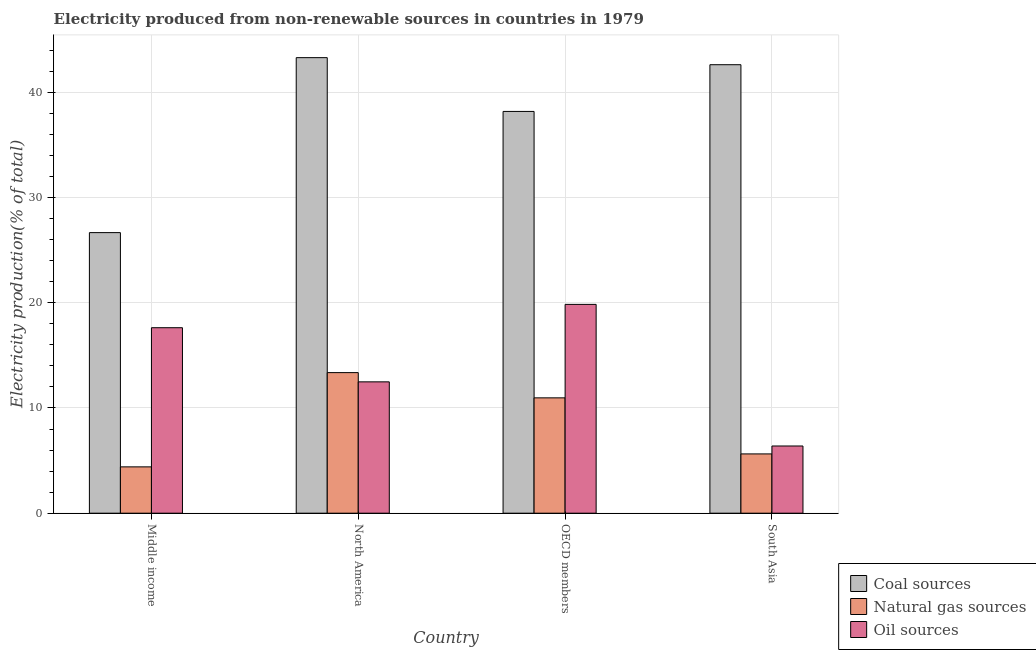How many different coloured bars are there?
Your answer should be compact. 3. How many groups of bars are there?
Your response must be concise. 4. How many bars are there on the 1st tick from the left?
Your response must be concise. 3. How many bars are there on the 3rd tick from the right?
Offer a very short reply. 3. What is the percentage of electricity produced by oil sources in Middle income?
Offer a very short reply. 17.63. Across all countries, what is the maximum percentage of electricity produced by oil sources?
Give a very brief answer. 19.85. Across all countries, what is the minimum percentage of electricity produced by natural gas?
Your response must be concise. 4.4. In which country was the percentage of electricity produced by oil sources minimum?
Offer a terse response. South Asia. What is the total percentage of electricity produced by natural gas in the graph?
Your answer should be compact. 34.36. What is the difference between the percentage of electricity produced by coal in Middle income and that in OECD members?
Provide a short and direct response. -11.52. What is the difference between the percentage of electricity produced by natural gas in Middle income and the percentage of electricity produced by oil sources in South Asia?
Offer a terse response. -1.98. What is the average percentage of electricity produced by coal per country?
Provide a succinct answer. 37.69. What is the difference between the percentage of electricity produced by natural gas and percentage of electricity produced by oil sources in South Asia?
Give a very brief answer. -0.75. What is the ratio of the percentage of electricity produced by coal in North America to that in OECD members?
Give a very brief answer. 1.13. What is the difference between the highest and the second highest percentage of electricity produced by coal?
Give a very brief answer. 0.67. What is the difference between the highest and the lowest percentage of electricity produced by coal?
Ensure brevity in your answer.  16.63. Is the sum of the percentage of electricity produced by natural gas in North America and South Asia greater than the maximum percentage of electricity produced by oil sources across all countries?
Offer a very short reply. No. What does the 3rd bar from the left in Middle income represents?
Provide a short and direct response. Oil sources. What does the 2nd bar from the right in North America represents?
Provide a short and direct response. Natural gas sources. Are all the bars in the graph horizontal?
Provide a short and direct response. No. Are the values on the major ticks of Y-axis written in scientific E-notation?
Offer a terse response. No. Does the graph contain any zero values?
Give a very brief answer. No. Does the graph contain grids?
Your answer should be compact. Yes. Where does the legend appear in the graph?
Provide a short and direct response. Bottom right. How many legend labels are there?
Offer a very short reply. 3. How are the legend labels stacked?
Your response must be concise. Vertical. What is the title of the graph?
Make the answer very short. Electricity produced from non-renewable sources in countries in 1979. What is the label or title of the X-axis?
Your answer should be very brief. Country. What is the label or title of the Y-axis?
Offer a very short reply. Electricity production(% of total). What is the Electricity production(% of total) of Coal sources in Middle income?
Your response must be concise. 26.66. What is the Electricity production(% of total) in Natural gas sources in Middle income?
Make the answer very short. 4.4. What is the Electricity production(% of total) in Oil sources in Middle income?
Offer a very short reply. 17.63. What is the Electricity production(% of total) of Coal sources in North America?
Provide a succinct answer. 43.29. What is the Electricity production(% of total) in Natural gas sources in North America?
Provide a succinct answer. 13.36. What is the Electricity production(% of total) of Oil sources in North America?
Offer a very short reply. 12.48. What is the Electricity production(% of total) in Coal sources in OECD members?
Your answer should be very brief. 38.18. What is the Electricity production(% of total) of Natural gas sources in OECD members?
Ensure brevity in your answer.  10.96. What is the Electricity production(% of total) of Oil sources in OECD members?
Your answer should be compact. 19.85. What is the Electricity production(% of total) in Coal sources in South Asia?
Make the answer very short. 42.62. What is the Electricity production(% of total) of Natural gas sources in South Asia?
Offer a very short reply. 5.63. What is the Electricity production(% of total) of Oil sources in South Asia?
Offer a terse response. 6.39. Across all countries, what is the maximum Electricity production(% of total) in Coal sources?
Offer a very short reply. 43.29. Across all countries, what is the maximum Electricity production(% of total) in Natural gas sources?
Ensure brevity in your answer.  13.36. Across all countries, what is the maximum Electricity production(% of total) of Oil sources?
Offer a very short reply. 19.85. Across all countries, what is the minimum Electricity production(% of total) of Coal sources?
Offer a terse response. 26.66. Across all countries, what is the minimum Electricity production(% of total) of Natural gas sources?
Your answer should be very brief. 4.4. Across all countries, what is the minimum Electricity production(% of total) in Oil sources?
Offer a very short reply. 6.39. What is the total Electricity production(% of total) in Coal sources in the graph?
Give a very brief answer. 150.76. What is the total Electricity production(% of total) in Natural gas sources in the graph?
Ensure brevity in your answer.  34.36. What is the total Electricity production(% of total) in Oil sources in the graph?
Your answer should be compact. 56.34. What is the difference between the Electricity production(% of total) of Coal sources in Middle income and that in North America?
Your response must be concise. -16.63. What is the difference between the Electricity production(% of total) in Natural gas sources in Middle income and that in North America?
Provide a short and direct response. -8.96. What is the difference between the Electricity production(% of total) of Oil sources in Middle income and that in North America?
Offer a terse response. 5.15. What is the difference between the Electricity production(% of total) of Coal sources in Middle income and that in OECD members?
Your answer should be compact. -11.52. What is the difference between the Electricity production(% of total) of Natural gas sources in Middle income and that in OECD members?
Give a very brief answer. -6.56. What is the difference between the Electricity production(% of total) of Oil sources in Middle income and that in OECD members?
Offer a very short reply. -2.22. What is the difference between the Electricity production(% of total) of Coal sources in Middle income and that in South Asia?
Offer a very short reply. -15.96. What is the difference between the Electricity production(% of total) of Natural gas sources in Middle income and that in South Asia?
Give a very brief answer. -1.23. What is the difference between the Electricity production(% of total) in Oil sources in Middle income and that in South Asia?
Your response must be concise. 11.24. What is the difference between the Electricity production(% of total) in Coal sources in North America and that in OECD members?
Offer a terse response. 5.11. What is the difference between the Electricity production(% of total) in Natural gas sources in North America and that in OECD members?
Keep it short and to the point. 2.4. What is the difference between the Electricity production(% of total) in Oil sources in North America and that in OECD members?
Your answer should be compact. -7.36. What is the difference between the Electricity production(% of total) in Coal sources in North America and that in South Asia?
Offer a very short reply. 0.67. What is the difference between the Electricity production(% of total) in Natural gas sources in North America and that in South Asia?
Ensure brevity in your answer.  7.73. What is the difference between the Electricity production(% of total) in Oil sources in North America and that in South Asia?
Offer a terse response. 6.1. What is the difference between the Electricity production(% of total) in Coal sources in OECD members and that in South Asia?
Ensure brevity in your answer.  -4.44. What is the difference between the Electricity production(% of total) in Natural gas sources in OECD members and that in South Asia?
Provide a short and direct response. 5.33. What is the difference between the Electricity production(% of total) in Oil sources in OECD members and that in South Asia?
Your response must be concise. 13.46. What is the difference between the Electricity production(% of total) in Coal sources in Middle income and the Electricity production(% of total) in Natural gas sources in North America?
Ensure brevity in your answer.  13.3. What is the difference between the Electricity production(% of total) in Coal sources in Middle income and the Electricity production(% of total) in Oil sources in North America?
Offer a terse response. 14.18. What is the difference between the Electricity production(% of total) in Natural gas sources in Middle income and the Electricity production(% of total) in Oil sources in North America?
Your answer should be very brief. -8.08. What is the difference between the Electricity production(% of total) in Coal sources in Middle income and the Electricity production(% of total) in Natural gas sources in OECD members?
Ensure brevity in your answer.  15.7. What is the difference between the Electricity production(% of total) of Coal sources in Middle income and the Electricity production(% of total) of Oil sources in OECD members?
Your response must be concise. 6.82. What is the difference between the Electricity production(% of total) in Natural gas sources in Middle income and the Electricity production(% of total) in Oil sources in OECD members?
Offer a very short reply. -15.44. What is the difference between the Electricity production(% of total) of Coal sources in Middle income and the Electricity production(% of total) of Natural gas sources in South Asia?
Your response must be concise. 21.03. What is the difference between the Electricity production(% of total) of Coal sources in Middle income and the Electricity production(% of total) of Oil sources in South Asia?
Make the answer very short. 20.28. What is the difference between the Electricity production(% of total) of Natural gas sources in Middle income and the Electricity production(% of total) of Oil sources in South Asia?
Ensure brevity in your answer.  -1.98. What is the difference between the Electricity production(% of total) in Coal sources in North America and the Electricity production(% of total) in Natural gas sources in OECD members?
Your answer should be compact. 32.33. What is the difference between the Electricity production(% of total) in Coal sources in North America and the Electricity production(% of total) in Oil sources in OECD members?
Keep it short and to the point. 23.45. What is the difference between the Electricity production(% of total) in Natural gas sources in North America and the Electricity production(% of total) in Oil sources in OECD members?
Your answer should be compact. -6.49. What is the difference between the Electricity production(% of total) of Coal sources in North America and the Electricity production(% of total) of Natural gas sources in South Asia?
Provide a succinct answer. 37.66. What is the difference between the Electricity production(% of total) in Coal sources in North America and the Electricity production(% of total) in Oil sources in South Asia?
Offer a terse response. 36.9. What is the difference between the Electricity production(% of total) in Natural gas sources in North America and the Electricity production(% of total) in Oil sources in South Asia?
Ensure brevity in your answer.  6.97. What is the difference between the Electricity production(% of total) in Coal sources in OECD members and the Electricity production(% of total) in Natural gas sources in South Asia?
Provide a short and direct response. 32.55. What is the difference between the Electricity production(% of total) of Coal sources in OECD members and the Electricity production(% of total) of Oil sources in South Asia?
Offer a terse response. 31.79. What is the difference between the Electricity production(% of total) of Natural gas sources in OECD members and the Electricity production(% of total) of Oil sources in South Asia?
Make the answer very short. 4.57. What is the average Electricity production(% of total) of Coal sources per country?
Provide a succinct answer. 37.69. What is the average Electricity production(% of total) in Natural gas sources per country?
Your answer should be compact. 8.59. What is the average Electricity production(% of total) in Oil sources per country?
Offer a terse response. 14.09. What is the difference between the Electricity production(% of total) in Coal sources and Electricity production(% of total) in Natural gas sources in Middle income?
Your answer should be very brief. 22.26. What is the difference between the Electricity production(% of total) of Coal sources and Electricity production(% of total) of Oil sources in Middle income?
Give a very brief answer. 9.04. What is the difference between the Electricity production(% of total) in Natural gas sources and Electricity production(% of total) in Oil sources in Middle income?
Provide a short and direct response. -13.22. What is the difference between the Electricity production(% of total) in Coal sources and Electricity production(% of total) in Natural gas sources in North America?
Provide a short and direct response. 29.93. What is the difference between the Electricity production(% of total) in Coal sources and Electricity production(% of total) in Oil sources in North America?
Give a very brief answer. 30.81. What is the difference between the Electricity production(% of total) of Natural gas sources and Electricity production(% of total) of Oil sources in North America?
Provide a short and direct response. 0.88. What is the difference between the Electricity production(% of total) of Coal sources and Electricity production(% of total) of Natural gas sources in OECD members?
Provide a succinct answer. 27.22. What is the difference between the Electricity production(% of total) in Coal sources and Electricity production(% of total) in Oil sources in OECD members?
Keep it short and to the point. 18.34. What is the difference between the Electricity production(% of total) in Natural gas sources and Electricity production(% of total) in Oil sources in OECD members?
Your answer should be very brief. -8.88. What is the difference between the Electricity production(% of total) of Coal sources and Electricity production(% of total) of Natural gas sources in South Asia?
Give a very brief answer. 36.99. What is the difference between the Electricity production(% of total) of Coal sources and Electricity production(% of total) of Oil sources in South Asia?
Provide a short and direct response. 36.23. What is the difference between the Electricity production(% of total) in Natural gas sources and Electricity production(% of total) in Oil sources in South Asia?
Make the answer very short. -0.75. What is the ratio of the Electricity production(% of total) in Coal sources in Middle income to that in North America?
Provide a succinct answer. 0.62. What is the ratio of the Electricity production(% of total) of Natural gas sources in Middle income to that in North America?
Give a very brief answer. 0.33. What is the ratio of the Electricity production(% of total) of Oil sources in Middle income to that in North America?
Make the answer very short. 1.41. What is the ratio of the Electricity production(% of total) of Coal sources in Middle income to that in OECD members?
Offer a terse response. 0.7. What is the ratio of the Electricity production(% of total) in Natural gas sources in Middle income to that in OECD members?
Your answer should be very brief. 0.4. What is the ratio of the Electricity production(% of total) of Oil sources in Middle income to that in OECD members?
Give a very brief answer. 0.89. What is the ratio of the Electricity production(% of total) in Coal sources in Middle income to that in South Asia?
Your answer should be compact. 0.63. What is the ratio of the Electricity production(% of total) of Natural gas sources in Middle income to that in South Asia?
Offer a very short reply. 0.78. What is the ratio of the Electricity production(% of total) of Oil sources in Middle income to that in South Asia?
Provide a short and direct response. 2.76. What is the ratio of the Electricity production(% of total) of Coal sources in North America to that in OECD members?
Make the answer very short. 1.13. What is the ratio of the Electricity production(% of total) of Natural gas sources in North America to that in OECD members?
Your response must be concise. 1.22. What is the ratio of the Electricity production(% of total) of Oil sources in North America to that in OECD members?
Provide a short and direct response. 0.63. What is the ratio of the Electricity production(% of total) of Coal sources in North America to that in South Asia?
Your answer should be compact. 1.02. What is the ratio of the Electricity production(% of total) in Natural gas sources in North America to that in South Asia?
Provide a short and direct response. 2.37. What is the ratio of the Electricity production(% of total) of Oil sources in North America to that in South Asia?
Offer a terse response. 1.95. What is the ratio of the Electricity production(% of total) of Coal sources in OECD members to that in South Asia?
Provide a short and direct response. 0.9. What is the ratio of the Electricity production(% of total) of Natural gas sources in OECD members to that in South Asia?
Keep it short and to the point. 1.95. What is the ratio of the Electricity production(% of total) of Oil sources in OECD members to that in South Asia?
Provide a short and direct response. 3.11. What is the difference between the highest and the second highest Electricity production(% of total) in Coal sources?
Your response must be concise. 0.67. What is the difference between the highest and the second highest Electricity production(% of total) of Natural gas sources?
Keep it short and to the point. 2.4. What is the difference between the highest and the second highest Electricity production(% of total) of Oil sources?
Make the answer very short. 2.22. What is the difference between the highest and the lowest Electricity production(% of total) in Coal sources?
Ensure brevity in your answer.  16.63. What is the difference between the highest and the lowest Electricity production(% of total) in Natural gas sources?
Keep it short and to the point. 8.96. What is the difference between the highest and the lowest Electricity production(% of total) of Oil sources?
Your answer should be very brief. 13.46. 